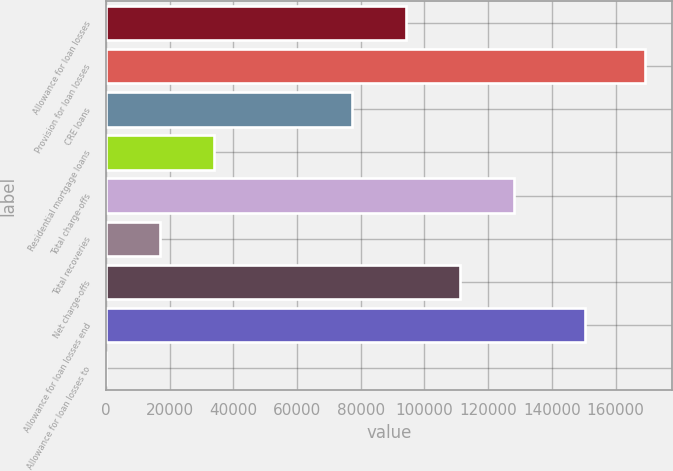Convert chart to OTSL. <chart><loc_0><loc_0><loc_500><loc_500><bar_chart><fcel>Allowance for loan losses<fcel>Provision for loan losses<fcel>CRE loans<fcel>Residential mortgage loans<fcel>Total charge-offs<fcel>Total recoveries<fcel>Net charge-offs<fcel>Allowance for loan losses end<fcel>Allowance for loan losses to<nl><fcel>94250.9<fcel>169341<fcel>77317<fcel>33870<fcel>128119<fcel>16936.1<fcel>111185<fcel>150272<fcel>2.23<nl></chart> 